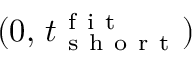<formula> <loc_0><loc_0><loc_500><loc_500>( 0 , \, t _ { s h o r t } ^ { f i t } )</formula> 